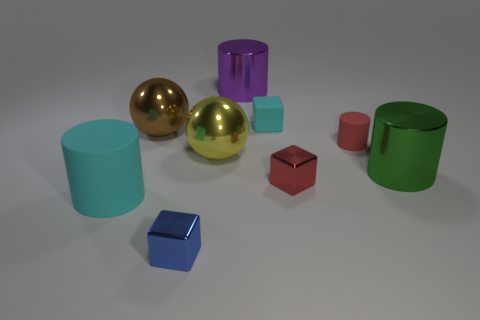Subtract all small matte cylinders. How many cylinders are left? 3 Subtract all cyan blocks. How many blocks are left? 2 Subtract 1 blocks. How many blocks are left? 2 Add 1 large balls. How many objects exist? 10 Add 6 brown objects. How many brown objects exist? 7 Subtract 0 yellow cylinders. How many objects are left? 9 Subtract all spheres. How many objects are left? 7 Subtract all cyan blocks. Subtract all green balls. How many blocks are left? 2 Subtract all tiny shiny blocks. Subtract all cylinders. How many objects are left? 3 Add 6 small blue objects. How many small blue objects are left? 7 